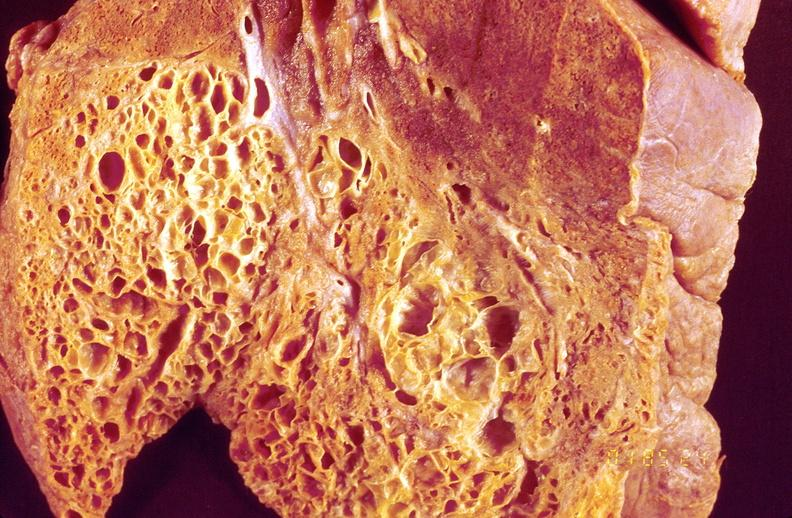what does this image show?
Answer the question using a single word or phrase. Lung fibrosis 